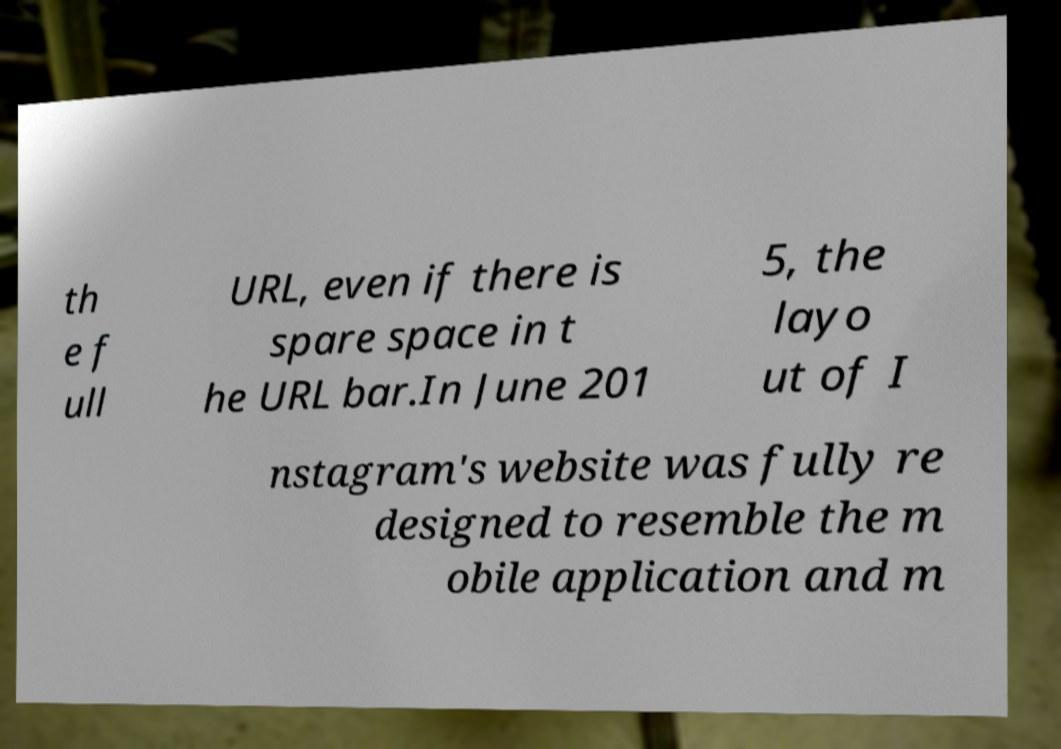There's text embedded in this image that I need extracted. Can you transcribe it verbatim? th e f ull URL, even if there is spare space in t he URL bar.In June 201 5, the layo ut of I nstagram's website was fully re designed to resemble the m obile application and m 